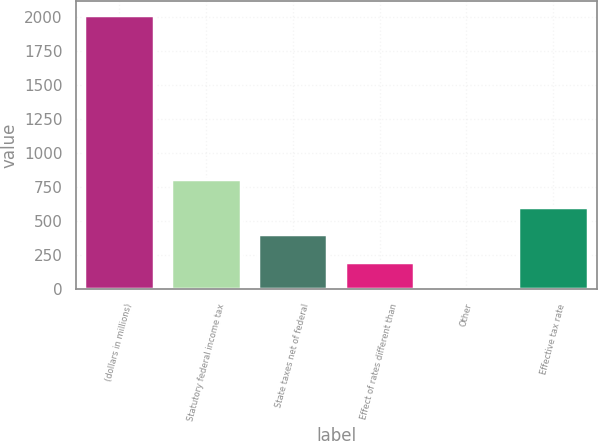Convert chart. <chart><loc_0><loc_0><loc_500><loc_500><bar_chart><fcel>(dollars in millions)<fcel>Statutory federal income tax<fcel>State taxes net of federal<fcel>Effect of rates different than<fcel>Other<fcel>Effective tax rate<nl><fcel>2013<fcel>805.62<fcel>403.16<fcel>201.93<fcel>0.7<fcel>604.39<nl></chart> 